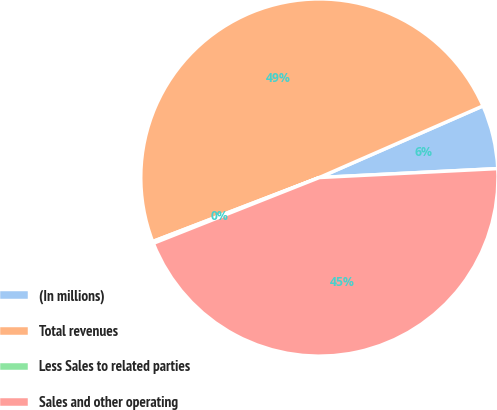Convert chart. <chart><loc_0><loc_0><loc_500><loc_500><pie_chart><fcel>(In millions)<fcel>Total revenues<fcel>Less Sales to related parties<fcel>Sales and other operating<nl><fcel>5.77%<fcel>49.27%<fcel>0.17%<fcel>44.79%<nl></chart> 